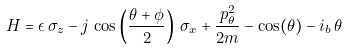Convert formula to latex. <formula><loc_0><loc_0><loc_500><loc_500>H = \epsilon \, \sigma _ { z } - j \, \cos \left ( \frac { \theta + \phi } { 2 } \right ) \, \sigma _ { x } + \frac { p _ { \theta } ^ { 2 } } { 2 m } - \cos ( \theta ) - i _ { b } \, \theta</formula> 